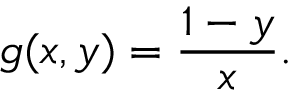<formula> <loc_0><loc_0><loc_500><loc_500>g ( x , y ) = { \frac { 1 - y } { x } } .</formula> 